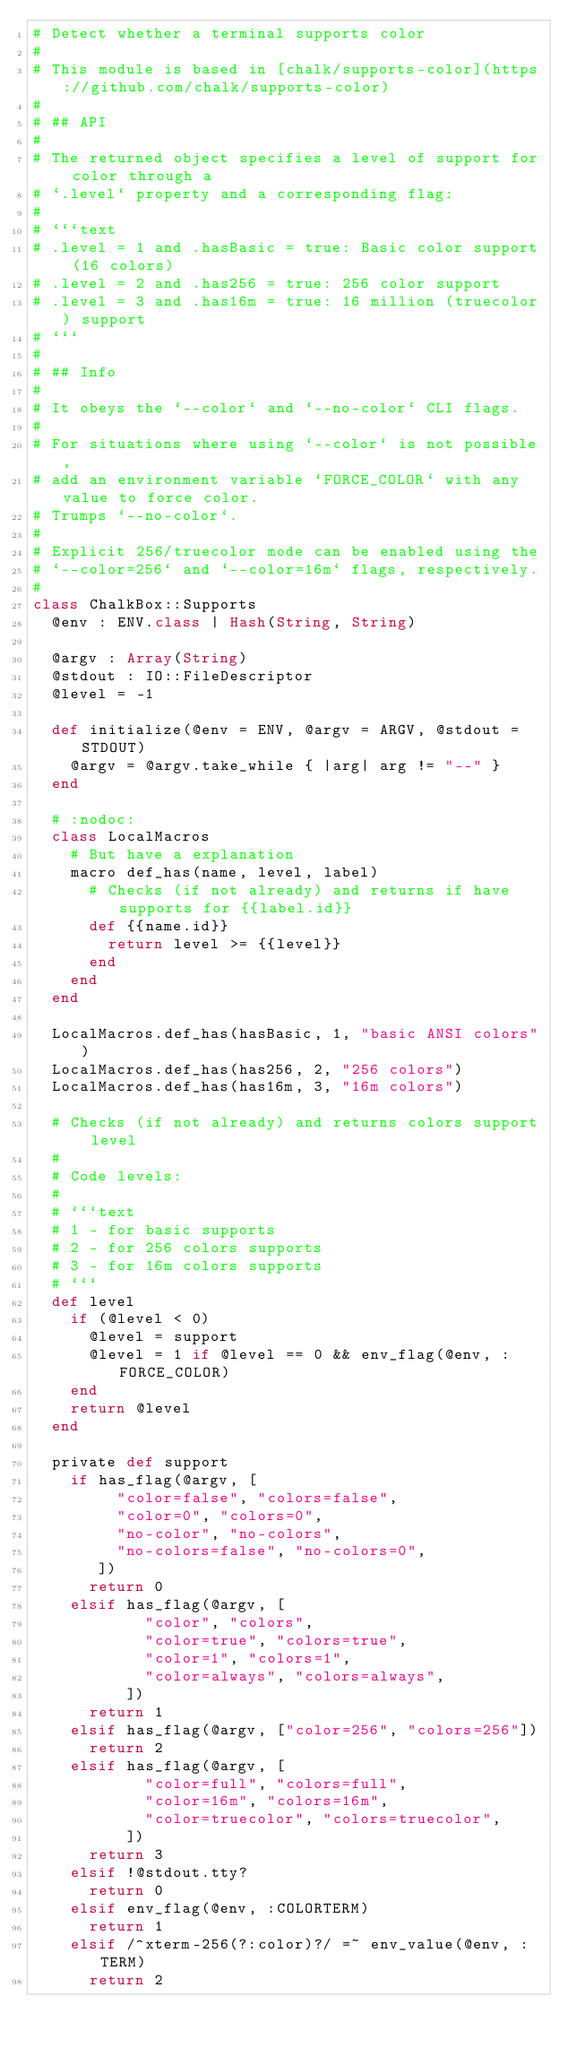Convert code to text. <code><loc_0><loc_0><loc_500><loc_500><_Crystal_># Detect whether a terminal supports color
#
# This module is based in [chalk/supports-color](https://github.com/chalk/supports-color)
#
# ## API
#
# The returned object specifies a level of support for color through a
# `.level` property and a corresponding flag:
#
# ```text
# .level = 1 and .hasBasic = true: Basic color support (16 colors)
# .level = 2 and .has256 = true: 256 color support
# .level = 3 and .has16m = true: 16 million (truecolor) support
# ```
#
# ## Info
#
# It obeys the `--color` and `--no-color` CLI flags.
#
# For situations where using `--color` is not possible,
# add an environment variable `FORCE_COLOR` with any value to force color.
# Trumps `--no-color`.
#
# Explicit 256/truecolor mode can be enabled using the
# `--color=256` and `--color=16m` flags, respectively.
#
class ChalkBox::Supports
  @env : ENV.class | Hash(String, String)

  @argv : Array(String)
  @stdout : IO::FileDescriptor
  @level = -1

  def initialize(@env = ENV, @argv = ARGV, @stdout = STDOUT)
    @argv = @argv.take_while { |arg| arg != "--" }
  end

  # :nodoc:
  class LocalMacros
    # But have a explanation
    macro def_has(name, level, label)
      # Checks (if not already) and returns if have supports for {{label.id}}
      def {{name.id}}
        return level >= {{level}}
      end
    end
  end

  LocalMacros.def_has(hasBasic, 1, "basic ANSI colors")
  LocalMacros.def_has(has256, 2, "256 colors")
  LocalMacros.def_has(has16m, 3, "16m colors")

  # Checks (if not already) and returns colors support level
  #
  # Code levels:
  #
  # ```text
  # 1 - for basic supports
  # 2 - for 256 colors supports
  # 3 - for 16m colors supports
  # ```
  def level
    if (@level < 0)
      @level = support
      @level = 1 if @level == 0 && env_flag(@env, :FORCE_COLOR)
    end
    return @level
  end

  private def support
    if has_flag(@argv, [
         "color=false", "colors=false",
         "color=0", "colors=0",
         "no-color", "no-colors",
         "no-colors=false", "no-colors=0",
       ])
      return 0
    elsif has_flag(@argv, [
            "color", "colors",
            "color=true", "colors=true",
            "color=1", "colors=1",
            "color=always", "colors=always",
          ])
      return 1
    elsif has_flag(@argv, ["color=256", "colors=256"])
      return 2
    elsif has_flag(@argv, [
            "color=full", "colors=full",
            "color=16m", "colors=16m",
            "color=truecolor", "colors=truecolor",
          ])
      return 3
    elsif !@stdout.tty?
      return 0
    elsif env_flag(@env, :COLORTERM)
      return 1
    elsif /^xterm-256(?:color)?/ =~ env_value(@env, :TERM)
      return 2</code> 